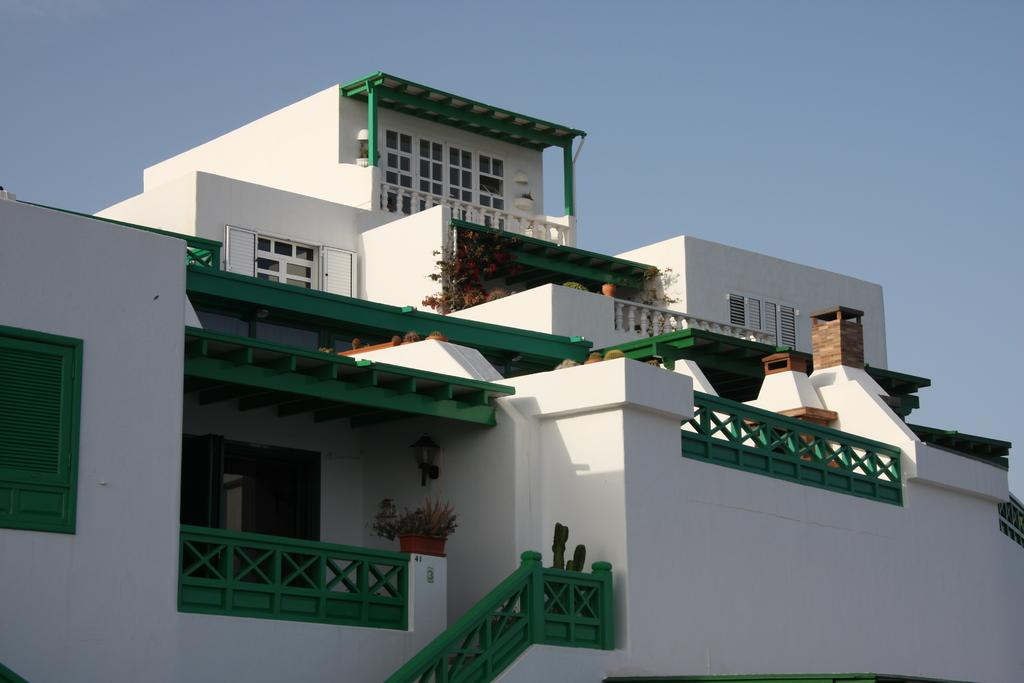What is the main subject of the image? The main subject of the image is a building. What perspective is the building shown from? The image shows the front view of the building. What type of advertisement can be seen on the building in the image? There is no advertisement visible on the building in the image. Is there a cap on the building in the image? There is no cap present on the building in the image. 